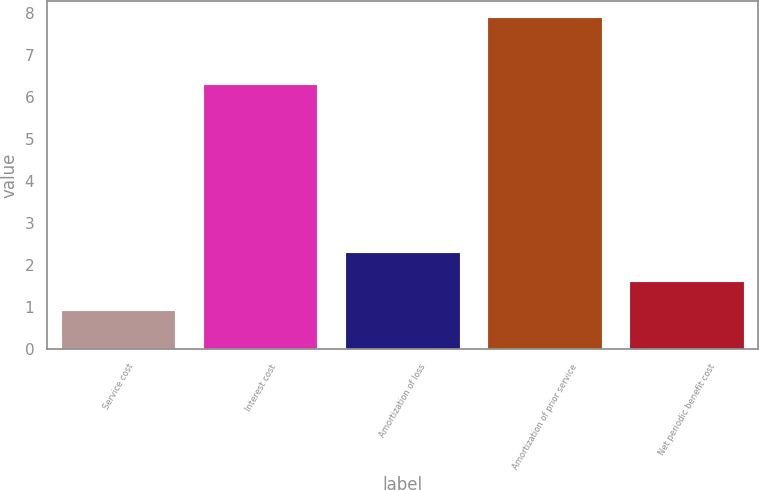Convert chart. <chart><loc_0><loc_0><loc_500><loc_500><bar_chart><fcel>Service cost<fcel>Interest cost<fcel>Amortization of loss<fcel>Amortization of prior service<fcel>Net periodic benefit cost<nl><fcel>0.9<fcel>6.3<fcel>2.3<fcel>7.9<fcel>1.6<nl></chart> 